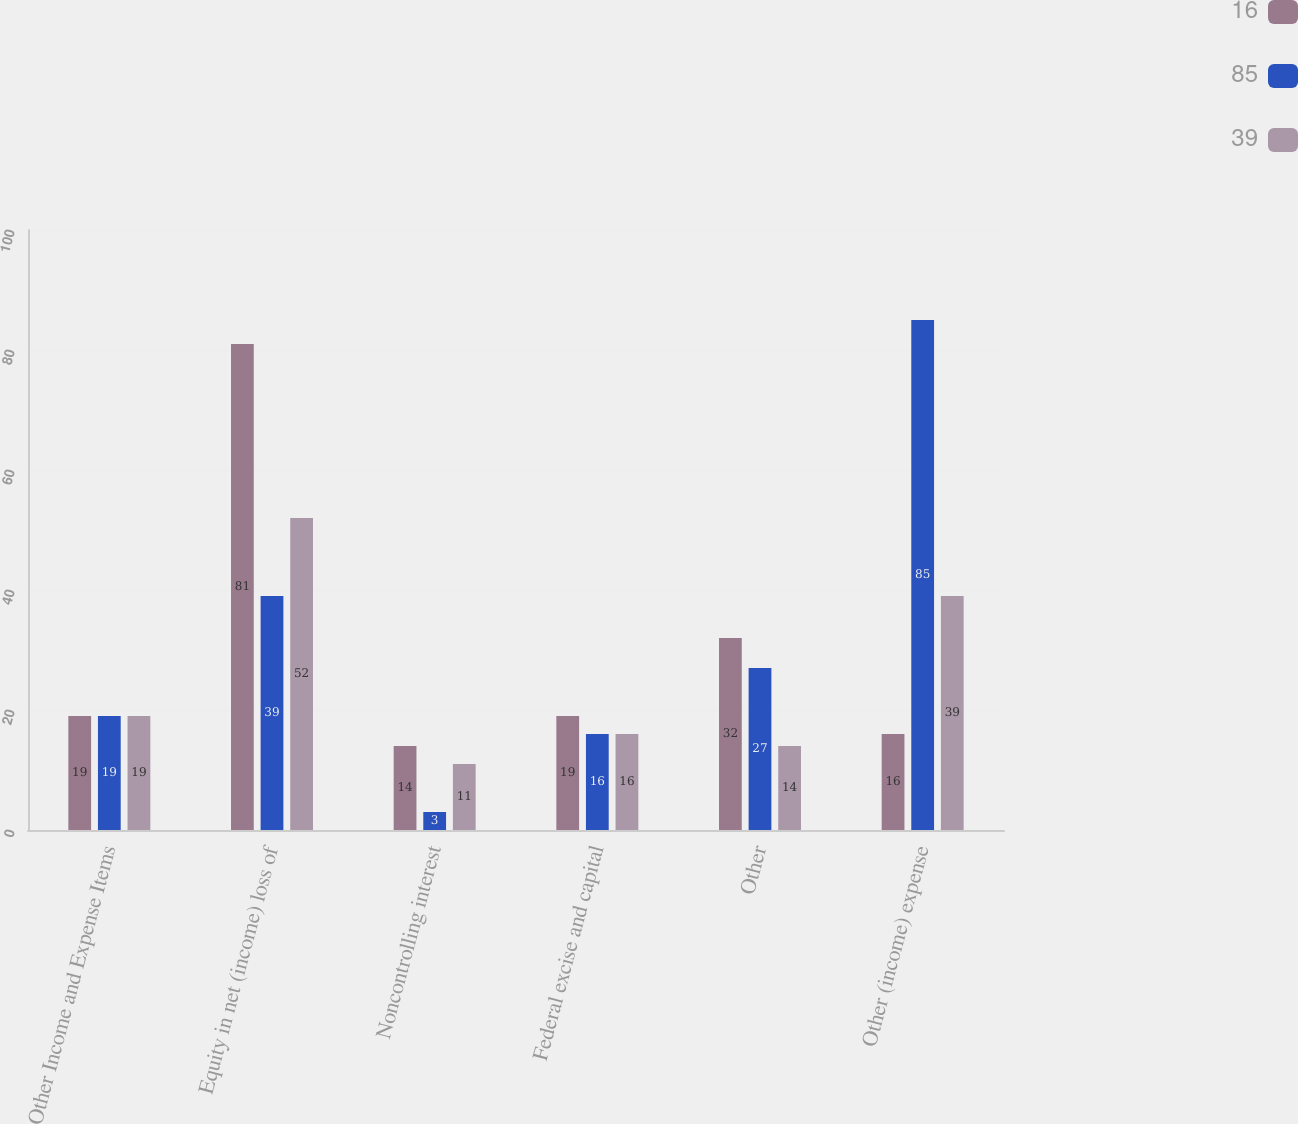Convert chart to OTSL. <chart><loc_0><loc_0><loc_500><loc_500><stacked_bar_chart><ecel><fcel>Other Income and Expense Items<fcel>Equity in net (income) loss of<fcel>Noncontrolling interest<fcel>Federal excise and capital<fcel>Other<fcel>Other (income) expense<nl><fcel>16<fcel>19<fcel>81<fcel>14<fcel>19<fcel>32<fcel>16<nl><fcel>85<fcel>19<fcel>39<fcel>3<fcel>16<fcel>27<fcel>85<nl><fcel>39<fcel>19<fcel>52<fcel>11<fcel>16<fcel>14<fcel>39<nl></chart> 